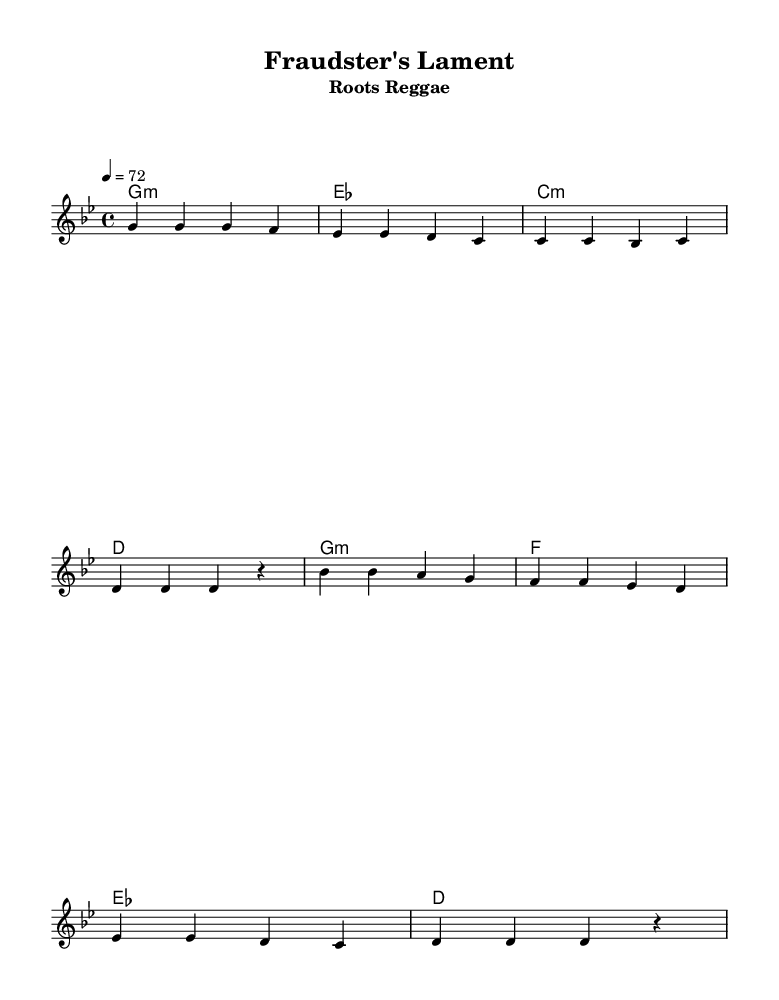What is the key signature of this music? The key signature is G minor, which has two flats: B flat and E flat. This is determined from the key signature indicator at the beginning of the staff.
Answer: G minor What is the time signature of the piece? The time signature is 4/4, indicated at the beginning of the sheet music. This means there are four beats in each measure and the quarter note gets one beat.
Answer: 4/4 What is the tempo marking for this piece? The tempo marking is 72 beats per minute, indicated as "4 = 72" at the start of the score. This tells the performer to play at a moderate speed.
Answer: 72 How many measures are in the verse? The verse consists of four measures, as counted from the music notation in the verse section of the sheet music.
Answer: 4 What type of chord progression is used in the verse? The chord progression in the verse follows a minor theme, specifically G minor, E flat, C minor, and D, indicating a use of minor chords typical in reggae music.
Answer: Minor How does the chorus differ from the verse in chord progression? The chorus features a different chord progression using G minor, F, E flat, and D, highlighting a shift in the harmonic structure compared to the verse.
Answer: Different What is the main theme addressed in the lyrics? The main theme of the lyrics addresses the consequences of insurance fraud, emphasizing karma and accountability, which aligns with the reggae style of conveying social messages.
Answer: Insurance fraud 